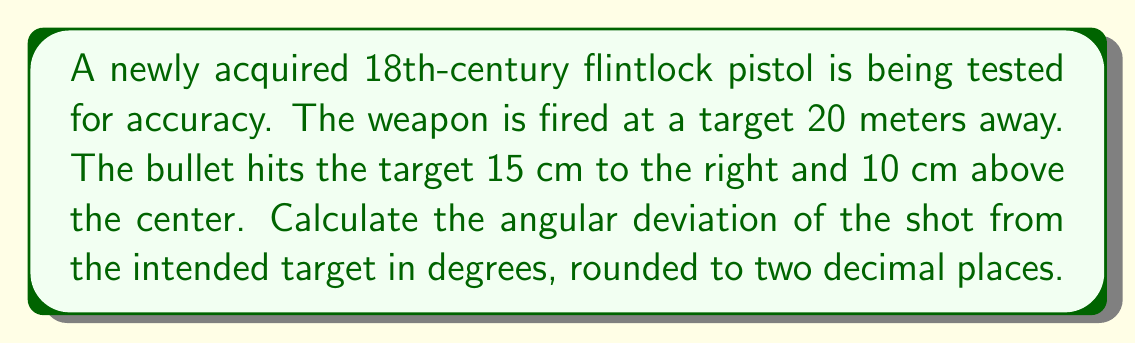Can you answer this question? To solve this problem, we need to use trigonometry to calculate the angle between the intended path and the actual path of the bullet. Let's break it down step-by-step:

1) First, we need to find the total deviation distance from the center of the target. We can use the Pythagorean theorem:

   $$d = \sqrt{15^2 + 10^2} = \sqrt{225 + 100} = \sqrt{325} \approx 18.03 \text{ cm}$$

2) Now we have a right triangle where:
   - The adjacent side is the distance to the target (20 meters = 2000 cm)
   - The opposite side is the deviation we just calculated (18.03 cm)

3) We can use the tangent function to find the angle:

   $$\tan(\theta) = \frac{\text{opposite}}{\text{adjacent}} = \frac{18.03}{2000}$$

4) To find the angle, we need to use the inverse tangent (arctan or $\tan^{-1}$):

   $$\theta = \tan^{-1}(\frac{18.03}{2000})$$

5) Calculate this value and convert to degrees:

   $$\theta = \tan^{-1}(0.009015) \approx 0.5164 \text{ radians}$$
   $$\theta \approx 0.5164 \times \frac{180}{\pi} \approx 29.59 \text{ degrees}$$

6) Rounding to two decimal places:

   $$\theta \approx 0.52 \text{ degrees}$$

This angular deviation represents the accuracy of the weapon, showing how far off the shot was from the intended target.

[asy]
unitsize(1cm);
draw((0,0)--(20,0),arrow=Arrow(TeXHead));
draw((0,0)--(20.15,0.18),arrow=Arrow(TeXHead));
draw((20,0)--(20.15,0.18),dashed);
label("20 m", (10,-0.5));
label("Target", (20,-0.5));
dot((20,0));
dot((20.15,0.18));
label("$\theta$", (0.5,0.1));
[/asy]
Answer: $0.52 \text{ degrees}$ 